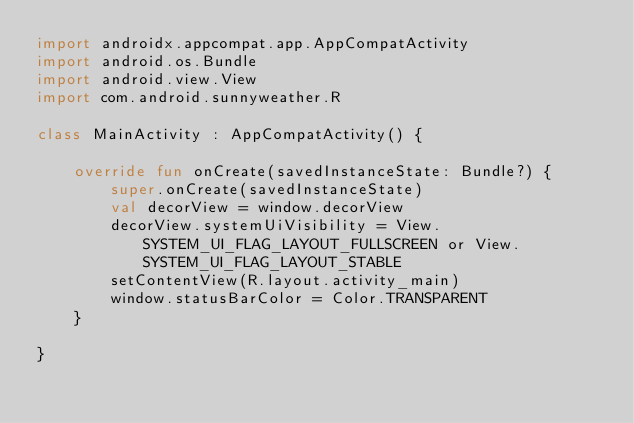<code> <loc_0><loc_0><loc_500><loc_500><_Kotlin_>import androidx.appcompat.app.AppCompatActivity
import android.os.Bundle
import android.view.View
import com.android.sunnyweather.R

class MainActivity : AppCompatActivity() {

    override fun onCreate(savedInstanceState: Bundle?) {
        super.onCreate(savedInstanceState)
        val decorView = window.decorView
        decorView.systemUiVisibility = View.SYSTEM_UI_FLAG_LAYOUT_FULLSCREEN or View.SYSTEM_UI_FLAG_LAYOUT_STABLE
        setContentView(R.layout.activity_main)
        window.statusBarColor = Color.TRANSPARENT
    }

}</code> 